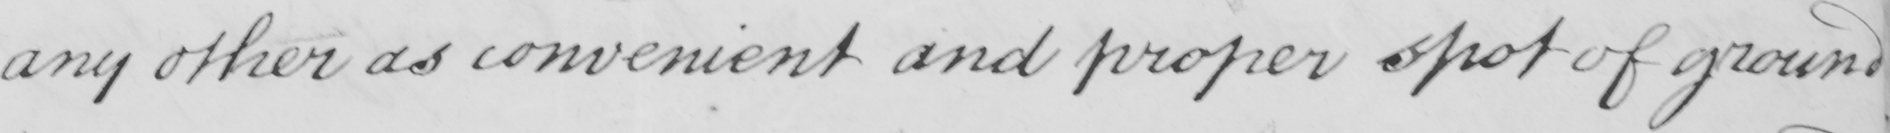Transcribe the text shown in this historical manuscript line. any other as convenient and proper spot of ground 